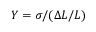<formula> <loc_0><loc_0><loc_500><loc_500>Y = \sigma / ( \Delta L / L )</formula> 